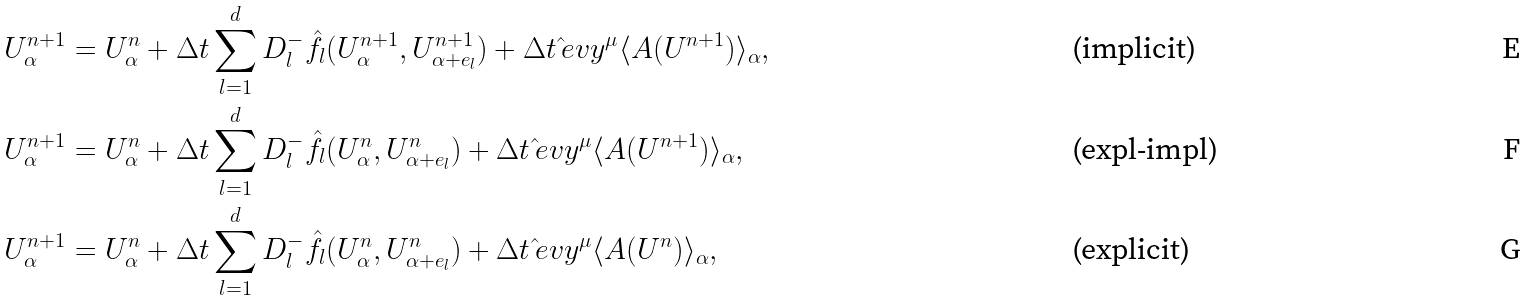Convert formula to latex. <formula><loc_0><loc_0><loc_500><loc_500>U _ { \alpha } ^ { n + 1 } & = U _ { \alpha } ^ { n } + \Delta t \sum _ { l = 1 } ^ { d } D _ { l } ^ { - } \hat { f } _ { l } ( U _ { \alpha } ^ { n + 1 } , U _ { \alpha + e _ { l } } ^ { n + 1 } ) + \Delta t \, \hat { \L } e v y ^ { \mu } \langle A ( U ^ { n + 1 } ) \rangle _ { \alpha } , & & \text {(implicit)} \\ U _ { \alpha } ^ { n + 1 } & = U _ { \alpha } ^ { n } + \Delta t \sum _ { l = 1 } ^ { d } D _ { l } ^ { - } \hat { f } _ { l } ( U _ { \alpha } ^ { n } , U _ { \alpha + e _ { l } } ^ { n } ) + \Delta t \, \hat { \L } e v y ^ { \mu } \langle A ( U ^ { n + 1 } ) \rangle _ { \alpha } , & & \text {(expl-impl)} \\ U _ { \alpha } ^ { n + 1 } & = U _ { \alpha } ^ { n } + \Delta t \sum _ { l = 1 } ^ { d } D _ { l } ^ { - } \hat { f } _ { l } ( U _ { \alpha } ^ { n } , U _ { \alpha + e _ { l } } ^ { n } ) + \Delta t \, \hat { \L } e v y ^ { \mu } \langle A ( U ^ { n } ) \rangle _ { \alpha } , & & \text {(explicit)}</formula> 